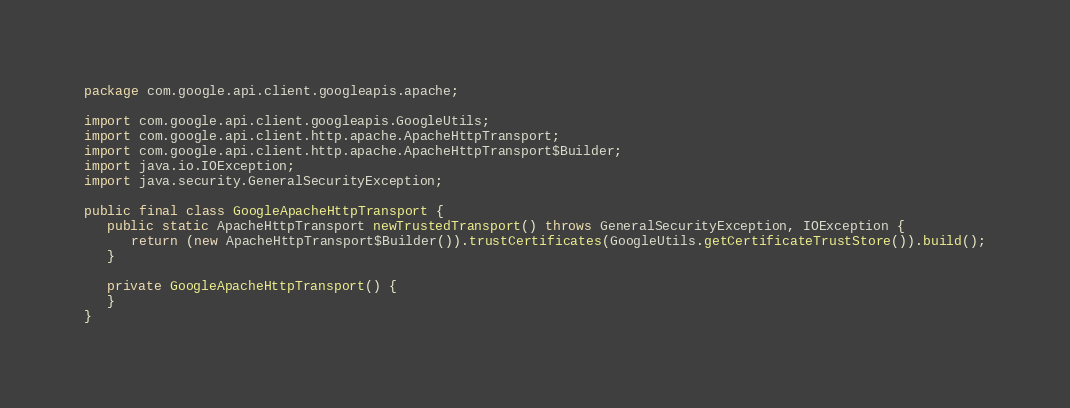Convert code to text. <code><loc_0><loc_0><loc_500><loc_500><_Java_>package com.google.api.client.googleapis.apache;

import com.google.api.client.googleapis.GoogleUtils;
import com.google.api.client.http.apache.ApacheHttpTransport;
import com.google.api.client.http.apache.ApacheHttpTransport$Builder;
import java.io.IOException;
import java.security.GeneralSecurityException;

public final class GoogleApacheHttpTransport {
   public static ApacheHttpTransport newTrustedTransport() throws GeneralSecurityException, IOException {
      return (new ApacheHttpTransport$Builder()).trustCertificates(GoogleUtils.getCertificateTrustStore()).build();
   }

   private GoogleApacheHttpTransport() {
   }
}
</code> 